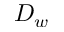Convert formula to latex. <formula><loc_0><loc_0><loc_500><loc_500>D _ { w }</formula> 